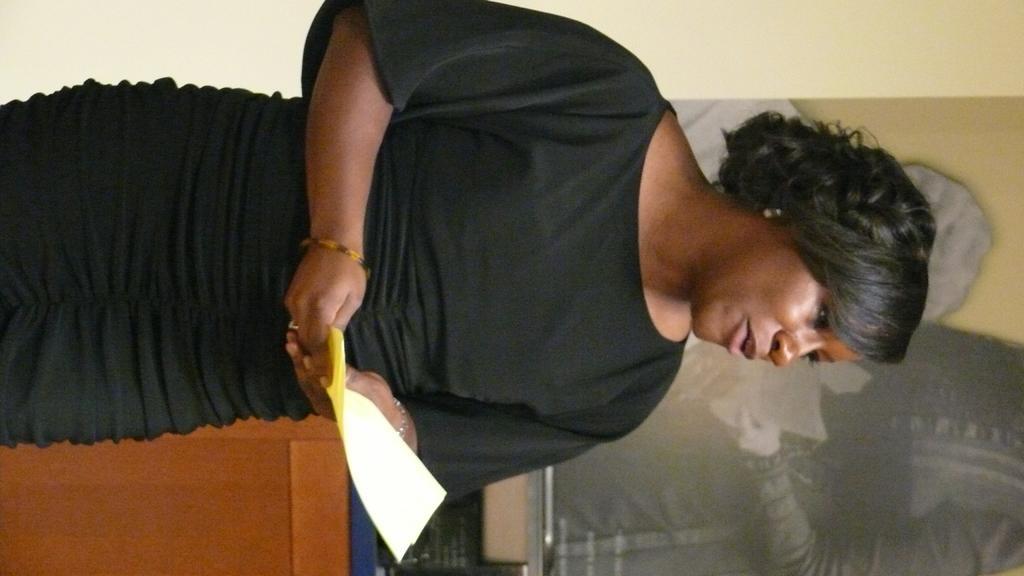Can you describe this image briefly? In this picture we can see a woman, she is holding few papers in her hands, in the background we can see a poster on the wall. 